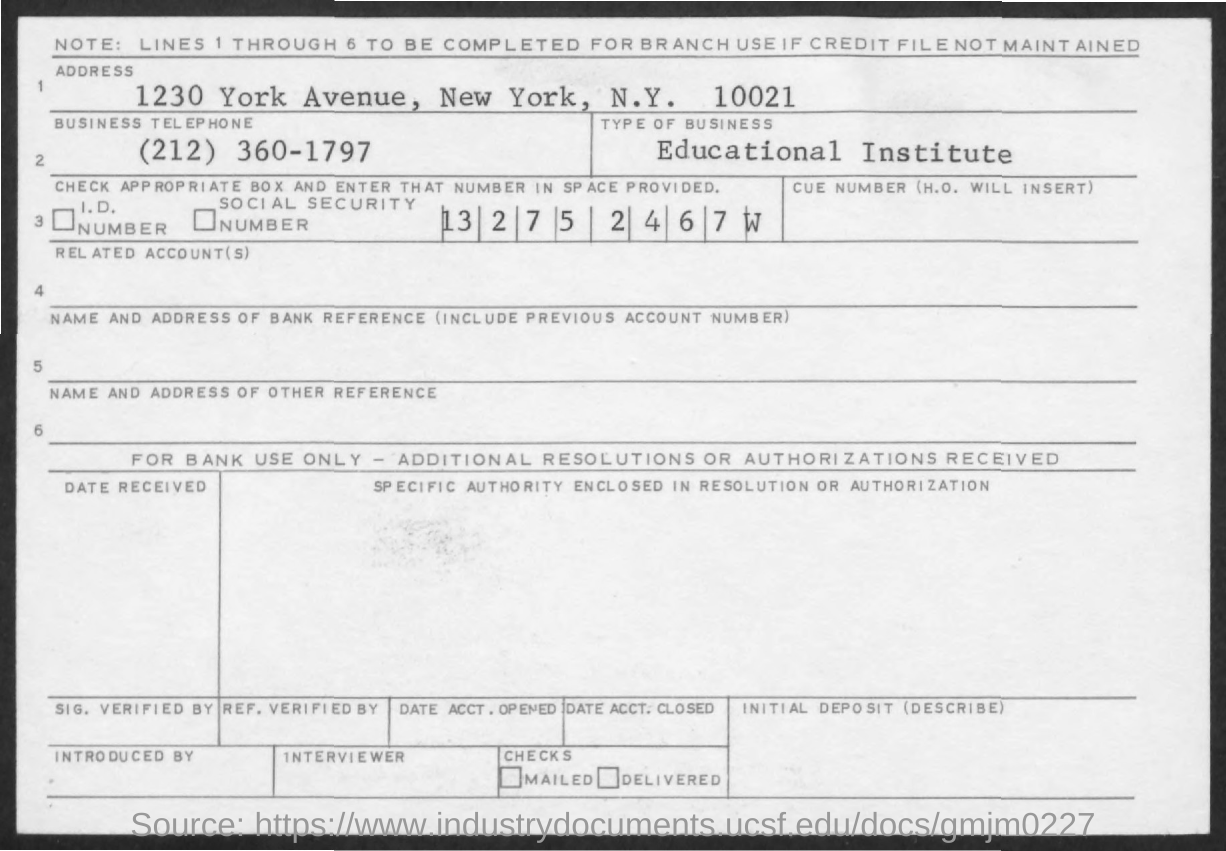Highlight a few significant elements in this photo. The business in question is an educational institution. The address mentioned is 1230 York Avenue, New York, N.Y. 10021. The business telephone number mentioned is (212) 360-1797. 